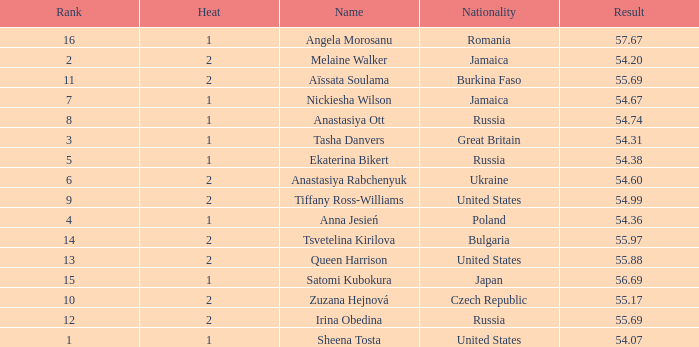Which Heat has a Nationality of bulgaria, and a Result larger than 55.97? None. 